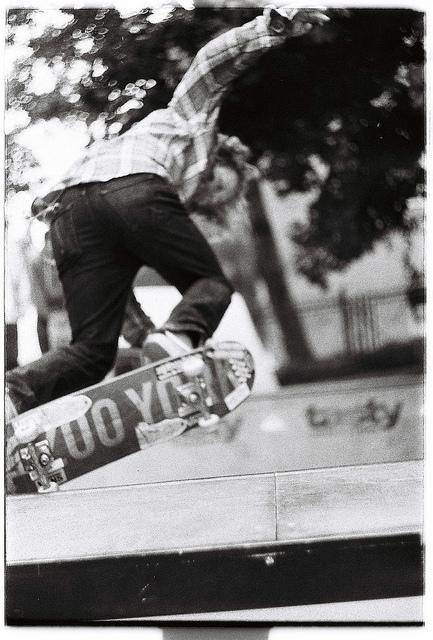What trick is being demonstrated in this photograph?
Write a very short answer. Jump. Is the person wearing a plaid shirt?
Quick response, please. Yes. Is this boy in the air?
Short answer required. Yes. Is he wearing a short sleeve shirt?
Write a very short answer. No. 